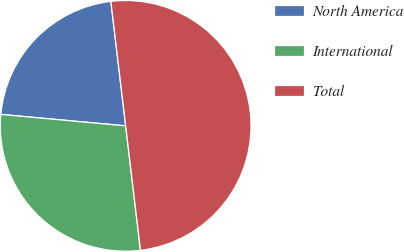<chart> <loc_0><loc_0><loc_500><loc_500><pie_chart><fcel>North America<fcel>International<fcel>Total<nl><fcel>21.66%<fcel>28.34%<fcel>50.0%<nl></chart> 